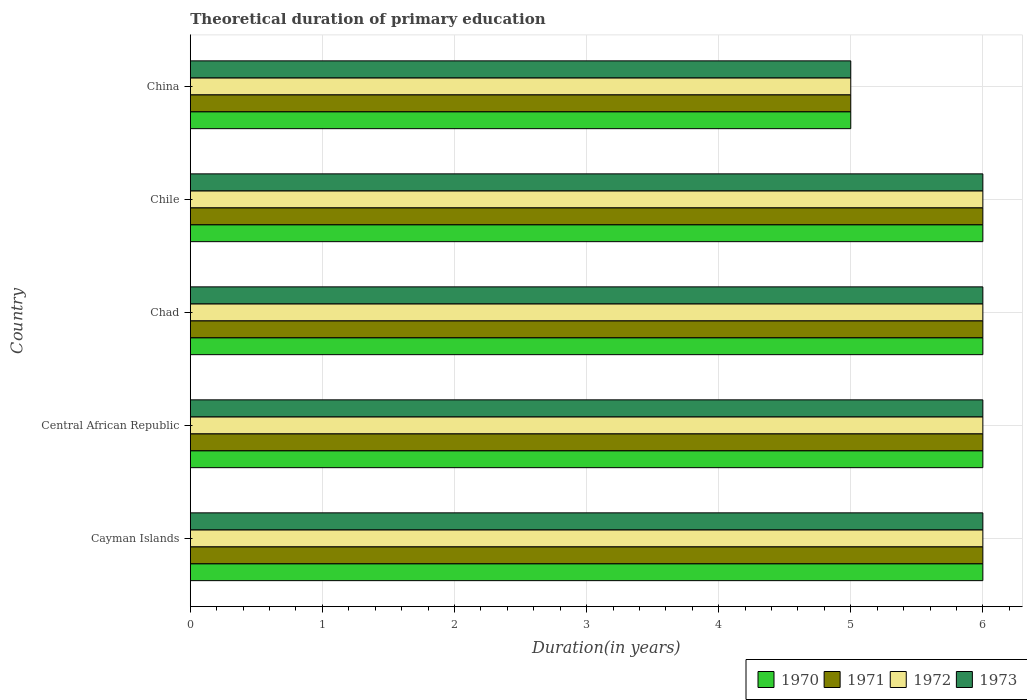How many different coloured bars are there?
Ensure brevity in your answer.  4. Are the number of bars per tick equal to the number of legend labels?
Make the answer very short. Yes. In how many cases, is the number of bars for a given country not equal to the number of legend labels?
Provide a succinct answer. 0. Across all countries, what is the minimum total theoretical duration of primary education in 1973?
Provide a succinct answer. 5. In which country was the total theoretical duration of primary education in 1971 maximum?
Provide a succinct answer. Cayman Islands. What is the total total theoretical duration of primary education in 1971 in the graph?
Ensure brevity in your answer.  29. What is the difference between the total theoretical duration of primary education in 1973 in Cayman Islands and that in Chad?
Ensure brevity in your answer.  0. What is the difference between the total theoretical duration of primary education in 1973 in Chile and the total theoretical duration of primary education in 1970 in China?
Provide a succinct answer. 1. What is the average total theoretical duration of primary education in 1970 per country?
Offer a very short reply. 5.8. In how many countries, is the total theoretical duration of primary education in 1970 greater than 4.4 years?
Your response must be concise. 5. What is the ratio of the total theoretical duration of primary education in 1970 in Cayman Islands to that in Chad?
Keep it short and to the point. 1. Is the difference between the total theoretical duration of primary education in 1972 in Chad and China greater than the difference between the total theoretical duration of primary education in 1971 in Chad and China?
Make the answer very short. No. What is the difference between the highest and the second highest total theoretical duration of primary education in 1971?
Ensure brevity in your answer.  0. In how many countries, is the total theoretical duration of primary education in 1970 greater than the average total theoretical duration of primary education in 1970 taken over all countries?
Provide a succinct answer. 4. Is it the case that in every country, the sum of the total theoretical duration of primary education in 1973 and total theoretical duration of primary education in 1971 is greater than the sum of total theoretical duration of primary education in 1972 and total theoretical duration of primary education in 1970?
Give a very brief answer. No. What does the 4th bar from the top in China represents?
Provide a succinct answer. 1970. Is it the case that in every country, the sum of the total theoretical duration of primary education in 1972 and total theoretical duration of primary education in 1973 is greater than the total theoretical duration of primary education in 1971?
Your answer should be very brief. Yes. How many bars are there?
Provide a succinct answer. 20. Are all the bars in the graph horizontal?
Provide a short and direct response. Yes. How many countries are there in the graph?
Give a very brief answer. 5. Are the values on the major ticks of X-axis written in scientific E-notation?
Make the answer very short. No. Does the graph contain any zero values?
Give a very brief answer. No. How many legend labels are there?
Provide a succinct answer. 4. What is the title of the graph?
Give a very brief answer. Theoretical duration of primary education. What is the label or title of the X-axis?
Provide a succinct answer. Duration(in years). What is the label or title of the Y-axis?
Provide a succinct answer. Country. What is the Duration(in years) in 1972 in Cayman Islands?
Your answer should be very brief. 6. What is the Duration(in years) of 1970 in Central African Republic?
Provide a succinct answer. 6. What is the Duration(in years) in 1970 in Chad?
Make the answer very short. 6. What is the Duration(in years) of 1971 in Chad?
Give a very brief answer. 6. What is the Duration(in years) in 1973 in Chad?
Keep it short and to the point. 6. What is the Duration(in years) of 1970 in Chile?
Your answer should be compact. 6. What is the Duration(in years) of 1972 in Chile?
Give a very brief answer. 6. What is the Duration(in years) of 1970 in China?
Make the answer very short. 5. What is the Duration(in years) in 1972 in China?
Keep it short and to the point. 5. What is the Duration(in years) in 1973 in China?
Offer a very short reply. 5. Across all countries, what is the maximum Duration(in years) in 1970?
Your answer should be compact. 6. Across all countries, what is the minimum Duration(in years) in 1972?
Provide a short and direct response. 5. Across all countries, what is the minimum Duration(in years) of 1973?
Ensure brevity in your answer.  5. What is the difference between the Duration(in years) of 1970 in Cayman Islands and that in Central African Republic?
Your response must be concise. 0. What is the difference between the Duration(in years) in 1971 in Cayman Islands and that in Central African Republic?
Your answer should be compact. 0. What is the difference between the Duration(in years) of 1972 in Cayman Islands and that in Central African Republic?
Provide a succinct answer. 0. What is the difference between the Duration(in years) in 1971 in Cayman Islands and that in Chad?
Make the answer very short. 0. What is the difference between the Duration(in years) of 1970 in Cayman Islands and that in Chile?
Your answer should be very brief. 0. What is the difference between the Duration(in years) in 1971 in Cayman Islands and that in Chile?
Your answer should be very brief. 0. What is the difference between the Duration(in years) of 1972 in Cayman Islands and that in Chile?
Offer a terse response. 0. What is the difference between the Duration(in years) of 1973 in Cayman Islands and that in Chile?
Your answer should be compact. 0. What is the difference between the Duration(in years) of 1973 in Cayman Islands and that in China?
Your response must be concise. 1. What is the difference between the Duration(in years) in 1970 in Central African Republic and that in Chad?
Provide a short and direct response. 0. What is the difference between the Duration(in years) in 1971 in Central African Republic and that in Chad?
Your response must be concise. 0. What is the difference between the Duration(in years) in 1973 in Central African Republic and that in Chad?
Give a very brief answer. 0. What is the difference between the Duration(in years) in 1971 in Central African Republic and that in Chile?
Make the answer very short. 0. What is the difference between the Duration(in years) of 1973 in Central African Republic and that in Chile?
Keep it short and to the point. 0. What is the difference between the Duration(in years) of 1972 in Central African Republic and that in China?
Make the answer very short. 1. What is the difference between the Duration(in years) of 1973 in Central African Republic and that in China?
Offer a terse response. 1. What is the difference between the Duration(in years) in 1970 in Chad and that in Chile?
Your answer should be very brief. 0. What is the difference between the Duration(in years) of 1971 in Chad and that in Chile?
Make the answer very short. 0. What is the difference between the Duration(in years) of 1972 in Chad and that in Chile?
Make the answer very short. 0. What is the difference between the Duration(in years) of 1973 in Chad and that in Chile?
Provide a succinct answer. 0. What is the difference between the Duration(in years) in 1971 in Chad and that in China?
Ensure brevity in your answer.  1. What is the difference between the Duration(in years) in 1973 in Chad and that in China?
Offer a very short reply. 1. What is the difference between the Duration(in years) of 1970 in Cayman Islands and the Duration(in years) of 1972 in Central African Republic?
Provide a succinct answer. 0. What is the difference between the Duration(in years) of 1970 in Cayman Islands and the Duration(in years) of 1973 in Central African Republic?
Ensure brevity in your answer.  0. What is the difference between the Duration(in years) of 1970 in Cayman Islands and the Duration(in years) of 1972 in Chad?
Make the answer very short. 0. What is the difference between the Duration(in years) in 1970 in Cayman Islands and the Duration(in years) in 1973 in Chad?
Your response must be concise. 0. What is the difference between the Duration(in years) of 1971 in Cayman Islands and the Duration(in years) of 1972 in Chad?
Keep it short and to the point. 0. What is the difference between the Duration(in years) of 1971 in Cayman Islands and the Duration(in years) of 1973 in Chad?
Provide a short and direct response. 0. What is the difference between the Duration(in years) of 1970 in Cayman Islands and the Duration(in years) of 1972 in Chile?
Provide a succinct answer. 0. What is the difference between the Duration(in years) in 1970 in Cayman Islands and the Duration(in years) in 1973 in Chile?
Provide a succinct answer. 0. What is the difference between the Duration(in years) of 1971 in Cayman Islands and the Duration(in years) of 1972 in Chile?
Ensure brevity in your answer.  0. What is the difference between the Duration(in years) in 1971 in Cayman Islands and the Duration(in years) in 1973 in Chile?
Keep it short and to the point. 0. What is the difference between the Duration(in years) in 1970 in Central African Republic and the Duration(in years) in 1972 in Chad?
Give a very brief answer. 0. What is the difference between the Duration(in years) of 1970 in Central African Republic and the Duration(in years) of 1973 in Chad?
Ensure brevity in your answer.  0. What is the difference between the Duration(in years) in 1971 in Central African Republic and the Duration(in years) in 1972 in Chad?
Provide a short and direct response. 0. What is the difference between the Duration(in years) of 1972 in Central African Republic and the Duration(in years) of 1973 in Chad?
Provide a short and direct response. 0. What is the difference between the Duration(in years) of 1970 in Central African Republic and the Duration(in years) of 1971 in Chile?
Provide a short and direct response. 0. What is the difference between the Duration(in years) of 1970 in Central African Republic and the Duration(in years) of 1972 in Chile?
Provide a short and direct response. 0. What is the difference between the Duration(in years) in 1970 in Central African Republic and the Duration(in years) in 1973 in Chile?
Your response must be concise. 0. What is the difference between the Duration(in years) of 1971 in Central African Republic and the Duration(in years) of 1972 in Chile?
Keep it short and to the point. 0. What is the difference between the Duration(in years) in 1970 in Central African Republic and the Duration(in years) in 1971 in China?
Your answer should be very brief. 1. What is the difference between the Duration(in years) in 1970 in Central African Republic and the Duration(in years) in 1972 in China?
Offer a terse response. 1. What is the difference between the Duration(in years) of 1971 in Central African Republic and the Duration(in years) of 1972 in China?
Your answer should be compact. 1. What is the difference between the Duration(in years) in 1971 in Central African Republic and the Duration(in years) in 1973 in China?
Your answer should be compact. 1. What is the difference between the Duration(in years) of 1970 in Chad and the Duration(in years) of 1971 in Chile?
Your response must be concise. 0. What is the difference between the Duration(in years) of 1971 in Chad and the Duration(in years) of 1972 in Chile?
Provide a short and direct response. 0. What is the difference between the Duration(in years) in 1970 in Chad and the Duration(in years) in 1971 in China?
Your answer should be compact. 1. What is the difference between the Duration(in years) in 1970 in Chad and the Duration(in years) in 1972 in China?
Your answer should be very brief. 1. What is the difference between the Duration(in years) in 1970 in Chile and the Duration(in years) in 1971 in China?
Ensure brevity in your answer.  1. What is the difference between the Duration(in years) in 1970 in Chile and the Duration(in years) in 1972 in China?
Give a very brief answer. 1. What is the difference between the Duration(in years) in 1970 in Chile and the Duration(in years) in 1973 in China?
Provide a short and direct response. 1. What is the difference between the Duration(in years) of 1971 in Chile and the Duration(in years) of 1972 in China?
Your answer should be compact. 1. What is the difference between the Duration(in years) in 1972 in Chile and the Duration(in years) in 1973 in China?
Your answer should be compact. 1. What is the average Duration(in years) of 1972 per country?
Provide a short and direct response. 5.8. What is the difference between the Duration(in years) of 1970 and Duration(in years) of 1971 in Cayman Islands?
Keep it short and to the point. 0. What is the difference between the Duration(in years) of 1971 and Duration(in years) of 1972 in Cayman Islands?
Give a very brief answer. 0. What is the difference between the Duration(in years) of 1972 and Duration(in years) of 1973 in Cayman Islands?
Ensure brevity in your answer.  0. What is the difference between the Duration(in years) in 1970 and Duration(in years) in 1971 in Central African Republic?
Provide a succinct answer. 0. What is the difference between the Duration(in years) of 1971 and Duration(in years) of 1972 in Central African Republic?
Make the answer very short. 0. What is the difference between the Duration(in years) in 1971 and Duration(in years) in 1973 in Central African Republic?
Provide a succinct answer. 0. What is the difference between the Duration(in years) of 1972 and Duration(in years) of 1973 in Central African Republic?
Make the answer very short. 0. What is the difference between the Duration(in years) in 1970 and Duration(in years) in 1972 in Chad?
Make the answer very short. 0. What is the difference between the Duration(in years) of 1970 and Duration(in years) of 1973 in Chad?
Your answer should be compact. 0. What is the difference between the Duration(in years) in 1971 and Duration(in years) in 1973 in Chad?
Provide a short and direct response. 0. What is the difference between the Duration(in years) of 1972 and Duration(in years) of 1973 in Chad?
Give a very brief answer. 0. What is the difference between the Duration(in years) of 1970 and Duration(in years) of 1971 in Chile?
Ensure brevity in your answer.  0. What is the difference between the Duration(in years) of 1971 and Duration(in years) of 1972 in Chile?
Provide a succinct answer. 0. What is the difference between the Duration(in years) in 1971 and Duration(in years) in 1973 in Chile?
Give a very brief answer. 0. What is the difference between the Duration(in years) in 1972 and Duration(in years) in 1973 in Chile?
Provide a succinct answer. 0. What is the difference between the Duration(in years) of 1971 and Duration(in years) of 1972 in China?
Give a very brief answer. 0. What is the difference between the Duration(in years) of 1971 and Duration(in years) of 1973 in China?
Your answer should be very brief. 0. What is the difference between the Duration(in years) of 1972 and Duration(in years) of 1973 in China?
Keep it short and to the point. 0. What is the ratio of the Duration(in years) of 1972 in Cayman Islands to that in Central African Republic?
Provide a succinct answer. 1. What is the ratio of the Duration(in years) of 1973 in Cayman Islands to that in Central African Republic?
Keep it short and to the point. 1. What is the ratio of the Duration(in years) in 1972 in Cayman Islands to that in Chad?
Your answer should be very brief. 1. What is the ratio of the Duration(in years) in 1970 in Cayman Islands to that in Chile?
Make the answer very short. 1. What is the ratio of the Duration(in years) of 1972 in Cayman Islands to that in Chile?
Give a very brief answer. 1. What is the ratio of the Duration(in years) of 1973 in Cayman Islands to that in Chile?
Ensure brevity in your answer.  1. What is the ratio of the Duration(in years) in 1970 in Cayman Islands to that in China?
Make the answer very short. 1.2. What is the ratio of the Duration(in years) in 1973 in Cayman Islands to that in China?
Give a very brief answer. 1.2. What is the ratio of the Duration(in years) in 1970 in Central African Republic to that in Chad?
Your answer should be compact. 1. What is the ratio of the Duration(in years) of 1972 in Central African Republic to that in Chad?
Offer a terse response. 1. What is the ratio of the Duration(in years) in 1973 in Central African Republic to that in Chad?
Provide a short and direct response. 1. What is the ratio of the Duration(in years) of 1970 in Central African Republic to that in Chile?
Ensure brevity in your answer.  1. What is the ratio of the Duration(in years) in 1970 in Central African Republic to that in China?
Provide a succinct answer. 1.2. What is the ratio of the Duration(in years) of 1972 in Central African Republic to that in China?
Give a very brief answer. 1.2. What is the ratio of the Duration(in years) of 1973 in Central African Republic to that in China?
Provide a short and direct response. 1.2. What is the ratio of the Duration(in years) in 1971 in Chad to that in Chile?
Keep it short and to the point. 1. What is the ratio of the Duration(in years) of 1973 in Chad to that in Chile?
Give a very brief answer. 1. What is the ratio of the Duration(in years) of 1970 in Chad to that in China?
Give a very brief answer. 1.2. What is the ratio of the Duration(in years) of 1970 in Chile to that in China?
Your response must be concise. 1.2. What is the ratio of the Duration(in years) in 1972 in Chile to that in China?
Offer a very short reply. 1.2. What is the difference between the highest and the second highest Duration(in years) of 1971?
Give a very brief answer. 0. What is the difference between the highest and the second highest Duration(in years) of 1972?
Your answer should be very brief. 0. What is the difference between the highest and the second highest Duration(in years) of 1973?
Offer a terse response. 0. What is the difference between the highest and the lowest Duration(in years) in 1973?
Provide a succinct answer. 1. 